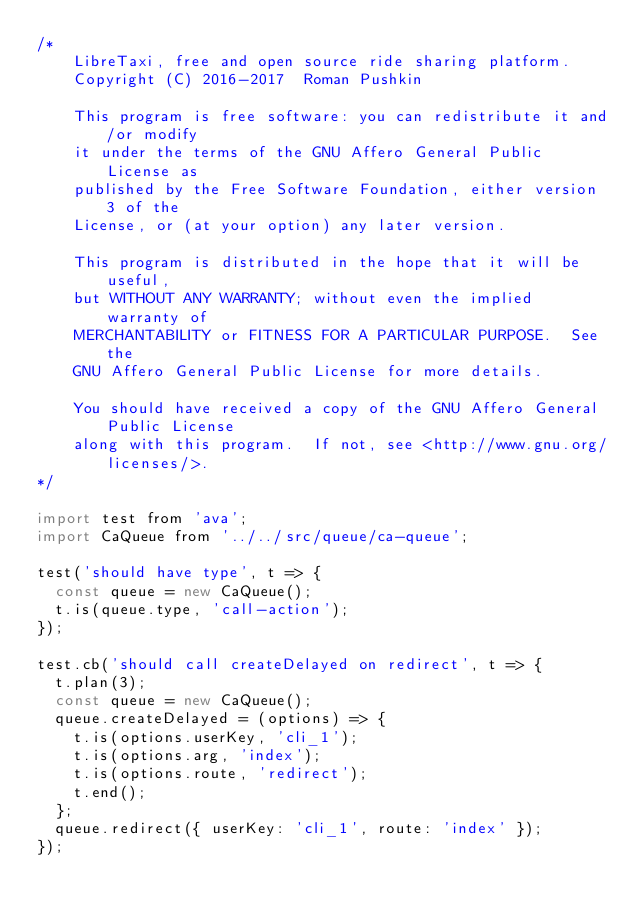Convert code to text. <code><loc_0><loc_0><loc_500><loc_500><_JavaScript_>/*
    LibreTaxi, free and open source ride sharing platform.
    Copyright (C) 2016-2017  Roman Pushkin

    This program is free software: you can redistribute it and/or modify
    it under the terms of the GNU Affero General Public License as
    published by the Free Software Foundation, either version 3 of the
    License, or (at your option) any later version.

    This program is distributed in the hope that it will be useful,
    but WITHOUT ANY WARRANTY; without even the implied warranty of
    MERCHANTABILITY or FITNESS FOR A PARTICULAR PURPOSE.  See the
    GNU Affero General Public License for more details.

    You should have received a copy of the GNU Affero General Public License
    along with this program.  If not, see <http://www.gnu.org/licenses/>.
*/

import test from 'ava';
import CaQueue from '../../src/queue/ca-queue';

test('should have type', t => {
  const queue = new CaQueue();
  t.is(queue.type, 'call-action');
});

test.cb('should call createDelayed on redirect', t => {
  t.plan(3);
  const queue = new CaQueue();
  queue.createDelayed = (options) => {
    t.is(options.userKey, 'cli_1');
    t.is(options.arg, 'index');
    t.is(options.route, 'redirect');
    t.end();
  };
  queue.redirect({ userKey: 'cli_1', route: 'index' });
});
</code> 